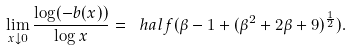<formula> <loc_0><loc_0><loc_500><loc_500>\lim _ { x \downarrow 0 } \frac { \log ( - b ( x ) ) } { \log x } = \ h a l f ( \beta - 1 + ( \beta ^ { 2 } + 2 \beta + 9 ) ^ { \frac { 1 } { 2 } } ) .</formula> 